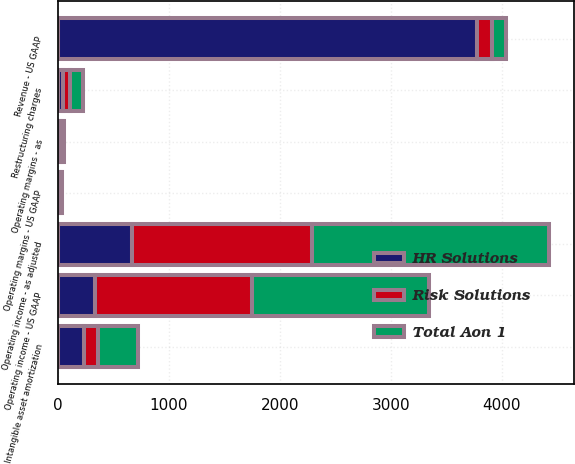Convert chart. <chart><loc_0><loc_0><loc_500><loc_500><stacked_bar_chart><ecel><fcel>Revenue - US GAAP<fcel>Operating income - US GAAP<fcel>Restructuring charges<fcel>Intangible asset amortization<fcel>Operating income - as adjusted<fcel>Operating margins - US GAAP<fcel>Operating margins - as<nl><fcel>Total Aon 1<fcel>129<fcel>1596<fcel>113<fcel>362<fcel>2139<fcel>14.1<fcel>19<nl><fcel>Risk Solutions<fcel>129<fcel>1413<fcel>65<fcel>129<fcel>1625<fcel>18.7<fcel>21.6<nl><fcel>HR Solutions<fcel>3781<fcel>336<fcel>48<fcel>233<fcel>664<fcel>8.9<fcel>17.6<nl></chart> 